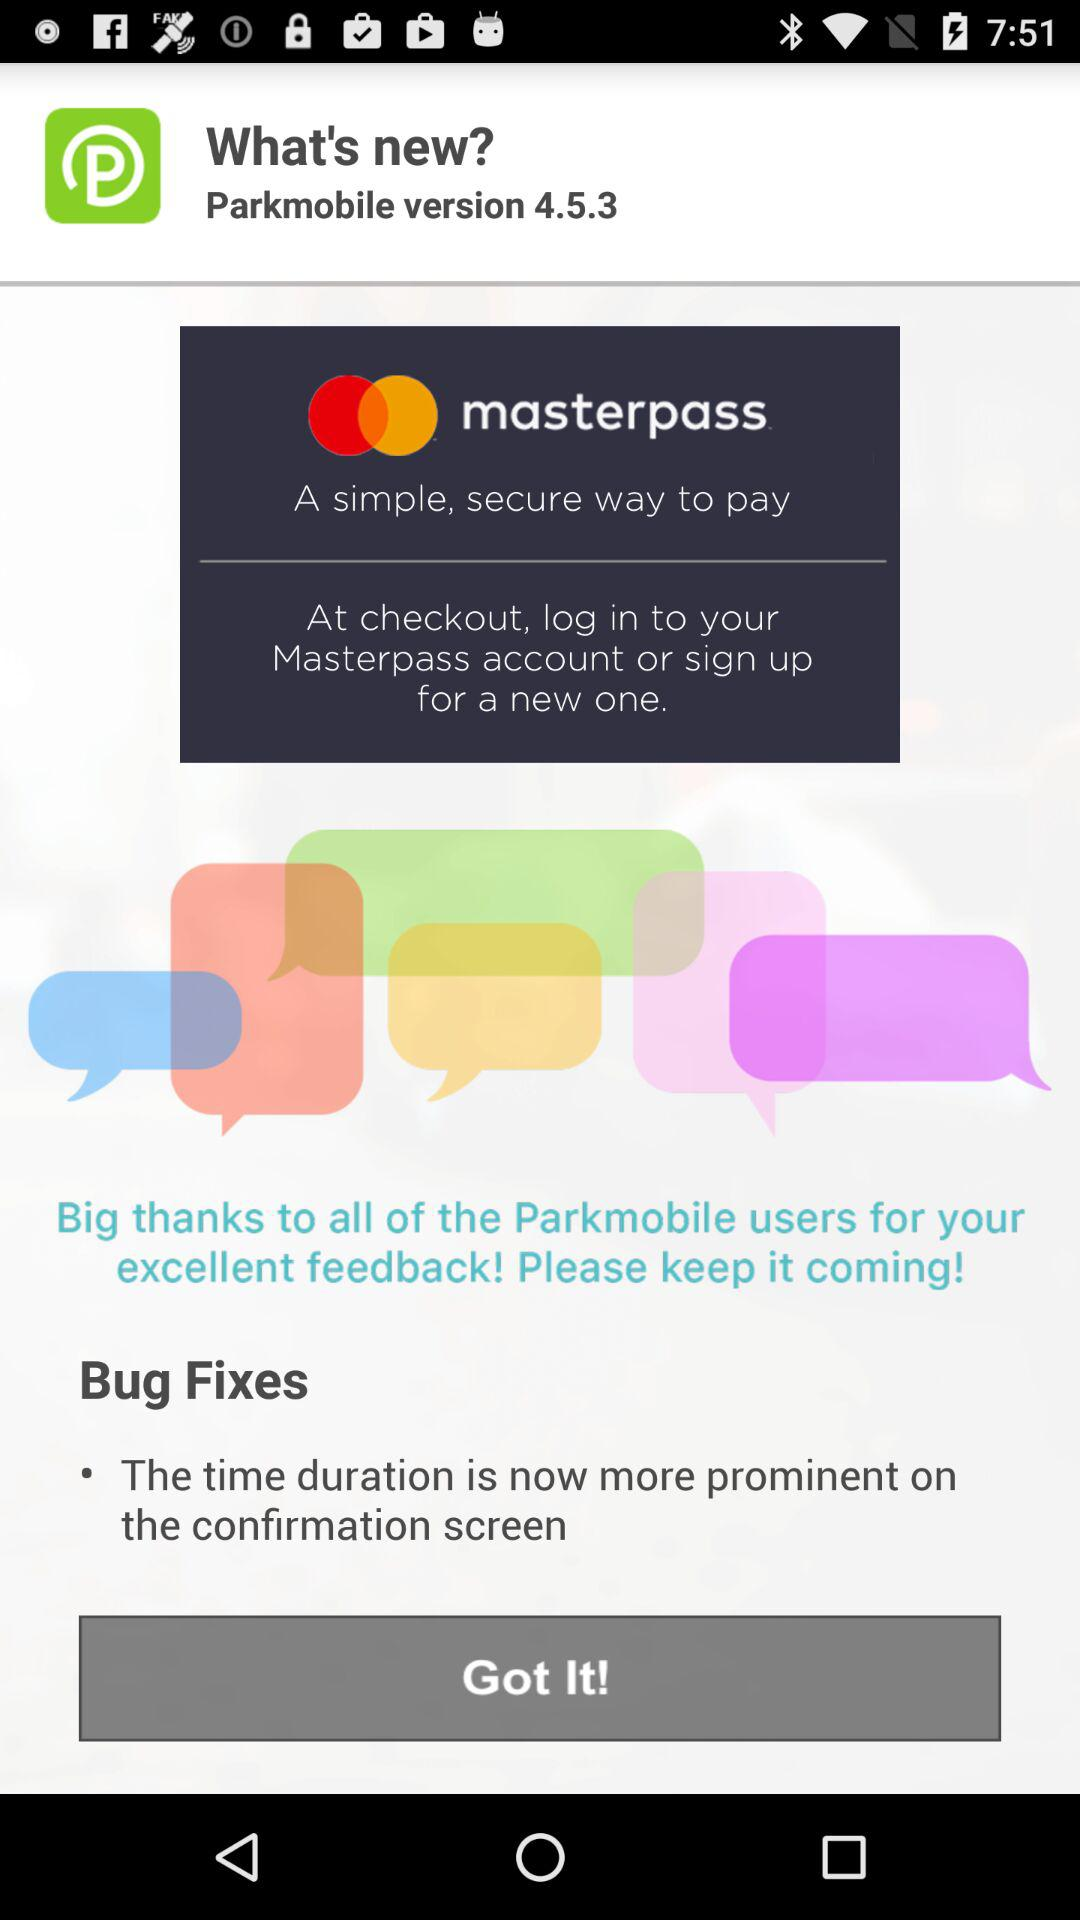What is the name of the application? The name of the application is "Parkmobile". 